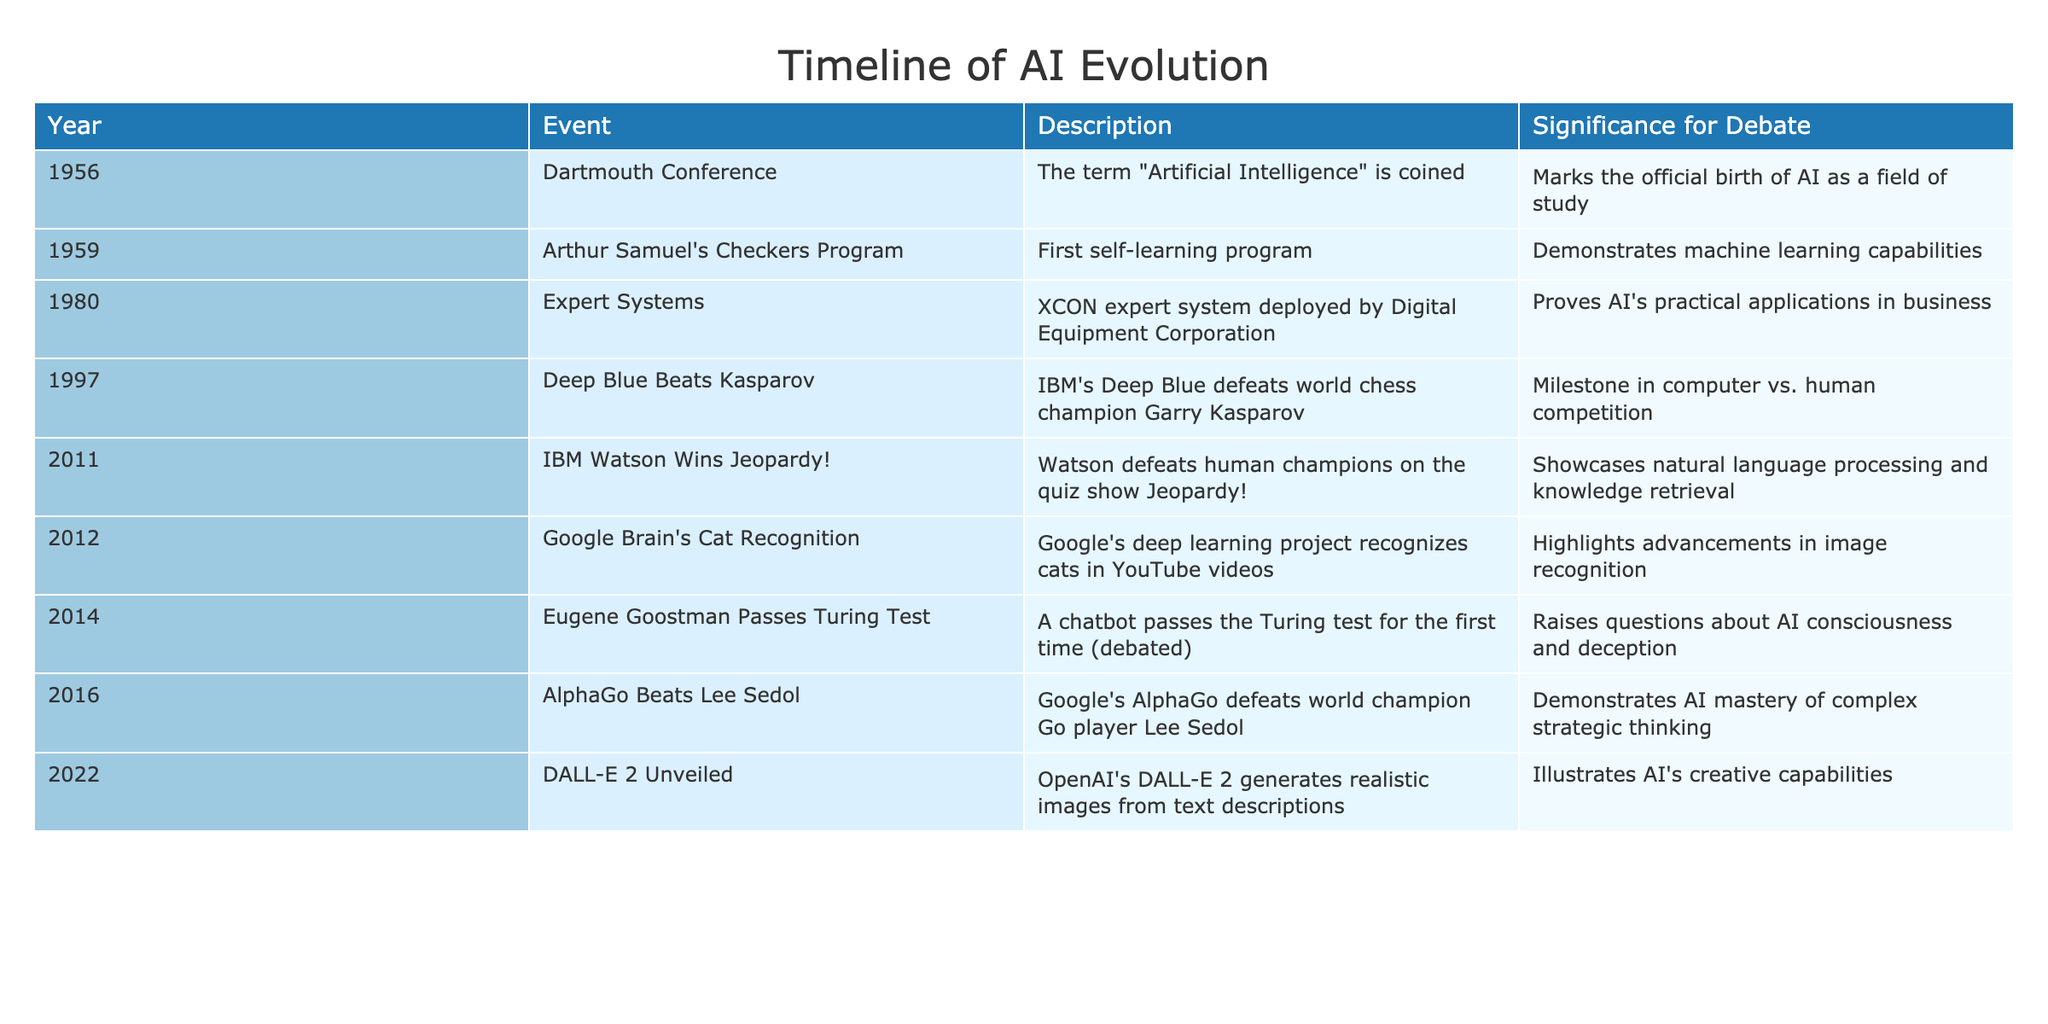What year was the Dartmouth Conference? The Dartmouth Conference is listed in the table and specifically identified in the first row under the "Year" column. It shows the year as 1956.
Answer: 1956 Which event in 1997 was significant for human-computer competition? The table indicates in the row for the year 1997 that IBM's Deep Blue defeated world chess champion Garry Kasparov, marking a significant event in the competition between humans and computers.
Answer: Deep Blue Beats Kasparov What were the contributions of the year 2011 in AI? According to the table, the year 2011 features IBM Watson winning Jeopardy!, which is described as showcasing natural language processing and knowledge retrieval. This is found directly in the event column for that year.
Answer: IBM Watson Wins Jeopardy! How many years passed between the invention of the first self-learning program and the Turing Test being passed? The first self-learning program was created in 1959 and the Turing Test was passed in 2014. We calculate the difference between these years as 2014 - 1959 = 55 years.
Answer: 55 years Is it true that the event involving AlphaGo took place before 2020? The event with AlphaGo defeating Lee Sedol happened in 2016, as indicated in the table. Since 2016 is before 2020, the statement is true.
Answer: Yes What is the significance of the event in 2012 related to image recognition? The table notes that in 2012, Google's deep learning project recognized various cats in YouTube videos. This event highlights advancements in image recognition, as explained in the significance column.
Answer: Highlights advancements in image recognition Which event between 2011 and 2022 shows AI's creative capabilities? Referring to the table, DALL-E 2 was unveiled in 2022 and is described as generating realistic images from text descriptions, showcasing AI's creative capabilities. This is found in the event and description columns of the 2022 row.
Answer: DALL-E 2 Unveiled How many total significant events were recorded from 1956 to 2022 in the table? Counting the number of rows/events in the table between the years specified, we find there are a total of 8 events listed from 1956 to 2022, each corresponding to a specific row.
Answer: 8 events What describes the significance of expert systems in 1980? The table shows that the XCON expert system was deployed by Digital Equipment Corporation in 1980, which is noted to prove AI's practical applications in business, elaborated in the significance column.
Answer: Proves AI's practical applications in business 